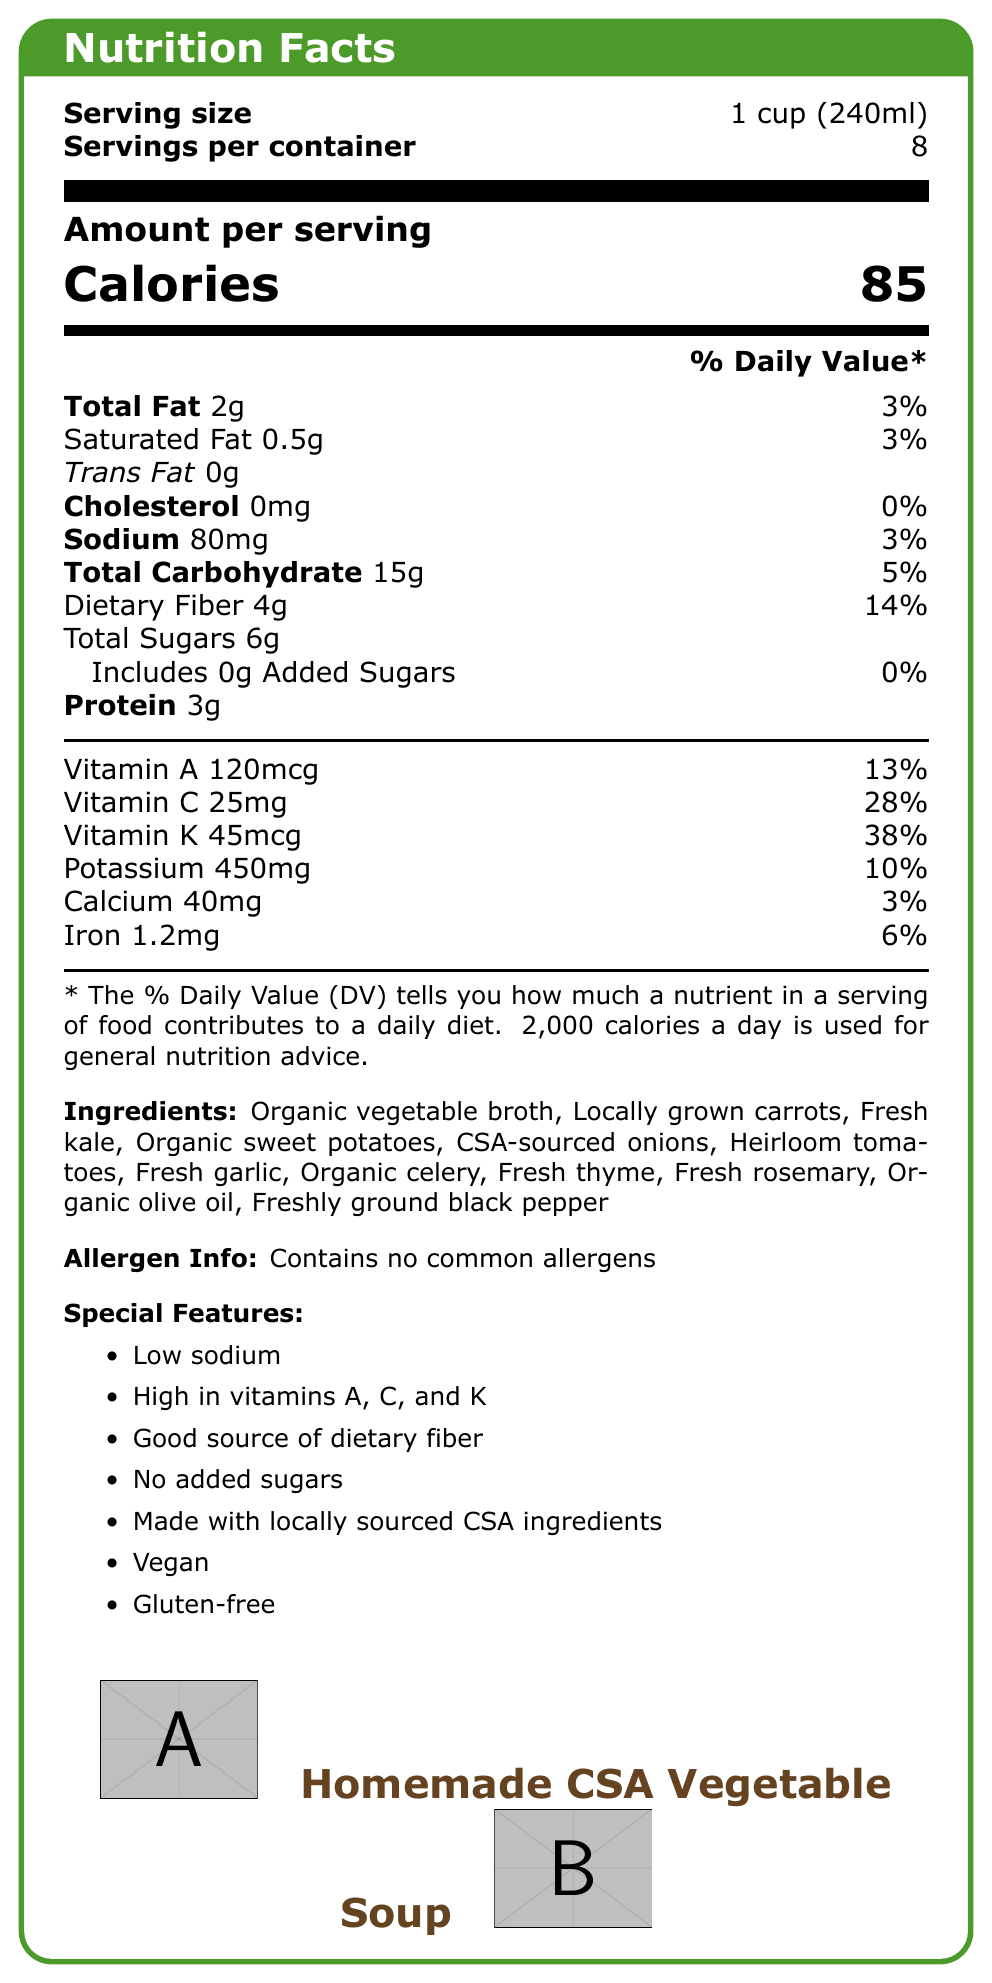what is the serving size? The serving size is mentioned at the top of the document as "Serving size: 1 cup (240ml)".
Answer: 1 cup (240ml) how many servings are in the container? The total number of servings per container is displayed right below the serving size as "Servings per container: 8".
Answer: 8 what is the total amount of sodium per serving? The sodium content per serving is listed in the document as "Sodium: 80mg".
Answer: 80mg what percentage of the daily value of vitamin C is provided per serving? The daily value percentage for vitamin C is specified as "Vitamin C 25mg 28%".
Answer: 28% what are the main ingredients used in the soup? The ingredients are listed under the section "Ingredients".
Answer: Organic vegetable broth, Locally grown carrots, Fresh kale, Organic sweet potatoes, CSA-sourced onions, Heirloom tomatoes, Fresh garlic, Organic celery, Fresh thyme, Fresh rosemary, Organic olive oil, Freshly ground black pepper what is the total number of calories per serving? The total number of calories per serving is shown prominently as "Calories 85".
Answer: 85 is the soup vegan? (Yes/No) The document lists "Vegan" under the section "Special Features".
Answer: Yes which vitamin has the highest percentage of daily value? A. Vitamin A B. Vitamin C C. Vitamin K The percentage of the daily value for Vitamin K is the highest with 38%, compared to Vitamin A (13%) and Vitamin C (28%).
Answer: C how much dietary fiber does one serving provide? The dietary fiber content per serving is provided as "Dietary Fiber 4g".
Answer: 4g what feature is highlighted about sodium content? Under "Special Features", "Low sodium" is listed, indicating the soup's sodium content is relatively low.
Answer: Low sodium how much iron is in one serving? A. 1.2mg B. 10mg C. 40mg D. 0mg The amount of iron per serving is shown as "Iron 1.2mg".
Answer: A how much potassium does each serving contain? The potassium content per serving is noted as "Potassium 450mg".
Answer: 450mg does the document provide information on protein content per serving? Under the nutrition facts, protein content is mentioned as "Protein 3g".
Answer: Yes summarize the main features of this homemade vegetable soup. The summary highlights the main points of the soup's nutritional value, special features, and its ingredients.
Answer: The homemade vegetable soup made with CSA ingredients offers 85 calories per serving, has low sodium (80mg), and is high in vitamins A (13%), C (28%), and K (38%). It’s a good source of dietary fiber (14%), vegan, gluten-free, and contains no common allergens. what is the total amount of carbohydrates per serving? The total carbohydrate amount per serving is provided as "Total Carbohydrate 15g".
Answer: 15g what percentage of daily value is the calcium content in each serving? The calcium daily value percentage is mentioned as "Calcium 40mg 3%".
Answer: 3% can it be determined what the expiry date of the soup is? The document does not provide any information on the expiry date of the soup.
Answer: Cannot be determined 